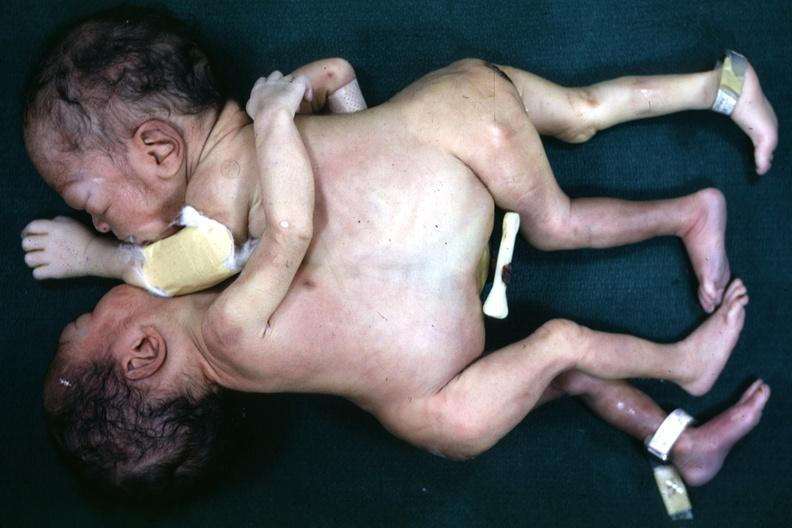what does this image show?
Answer the question using a single word or phrase. View from side showing fusion lower chest and entire abdomen single umbilical cord 